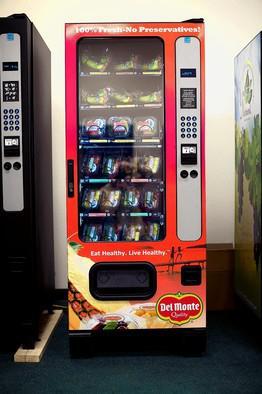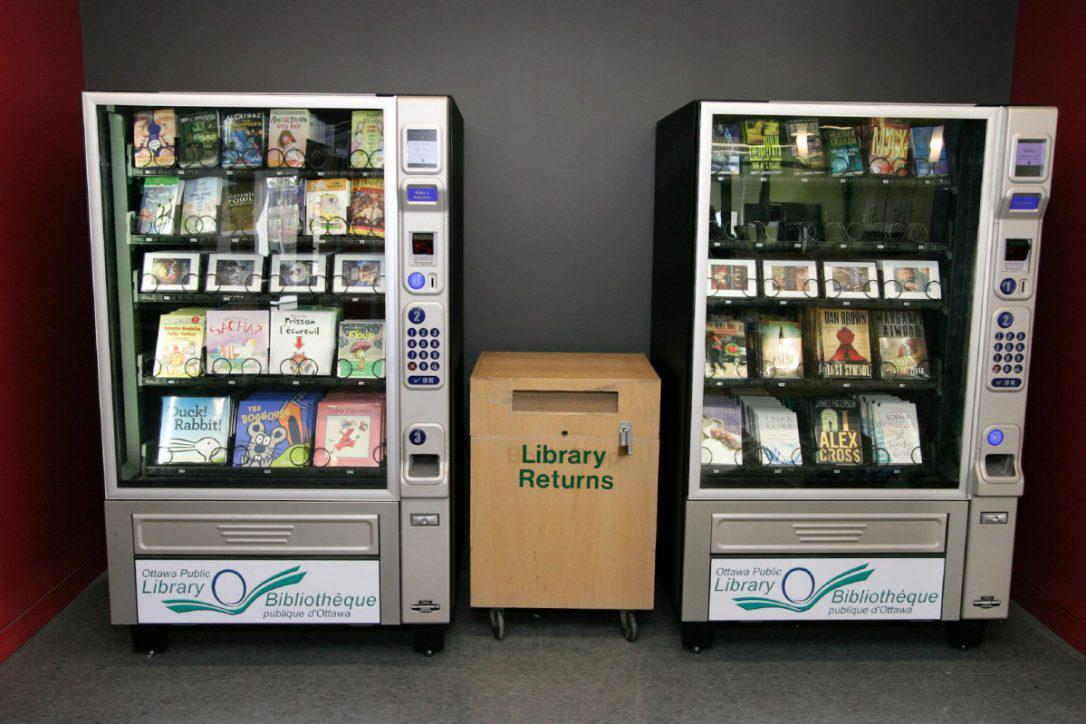The first image is the image on the left, the second image is the image on the right. For the images shown, is this caption "At least one beverage vending machine has a blue 'wet look' front." true? Answer yes or no. No. The first image is the image on the left, the second image is the image on the right. Assess this claim about the two images: "The left image contains at least one vending machine that is mostly blue in color.". Correct or not? Answer yes or no. No. 